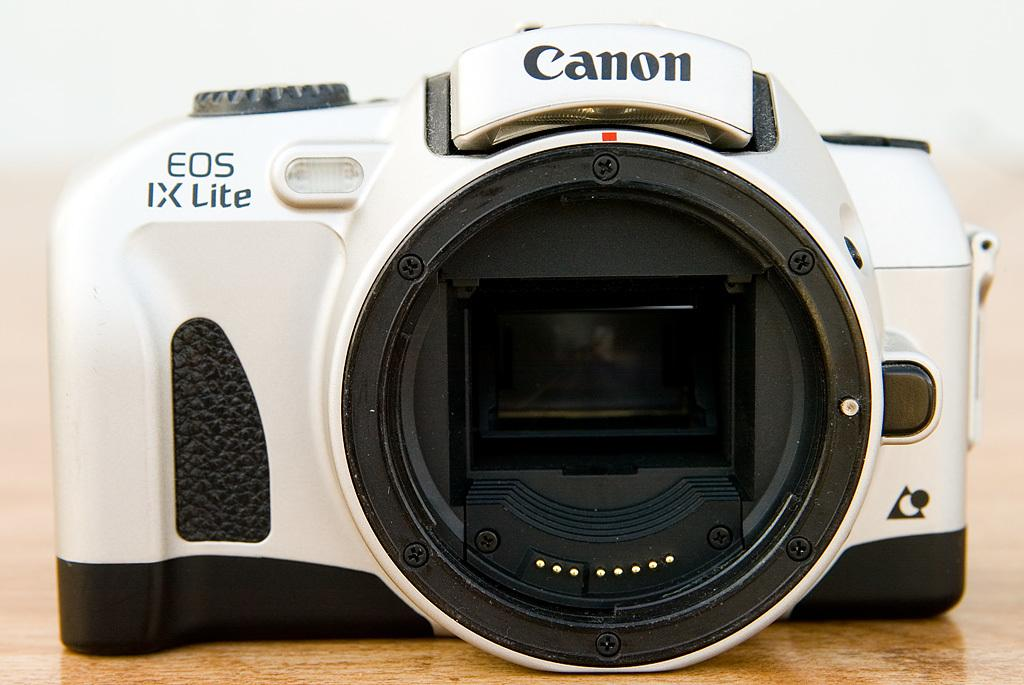What brand of camera is featured in the image? The camera in the image is from the Canon company. What color is the camera in the image? The camera is in black and white color. What type of table is visible in the image? There is no table present in the image; it only features a black and white Canon camera. What kind of apparatus is being used by the visitor in the image? There is no visitor or apparatus present in the image; it only features a black and white Canon camera. 